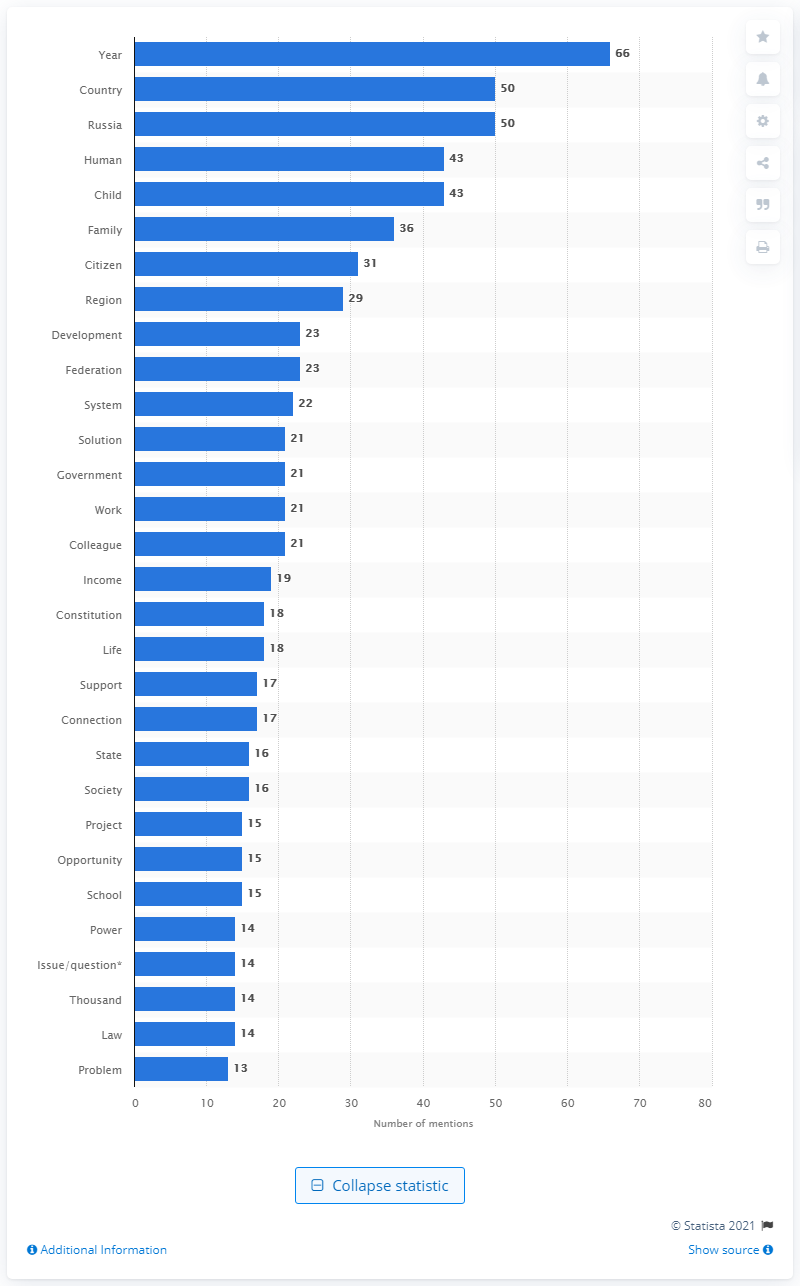List a handful of essential elements in this visual. Putin used the word "Constitution" 18 times in his 2020 speech. 